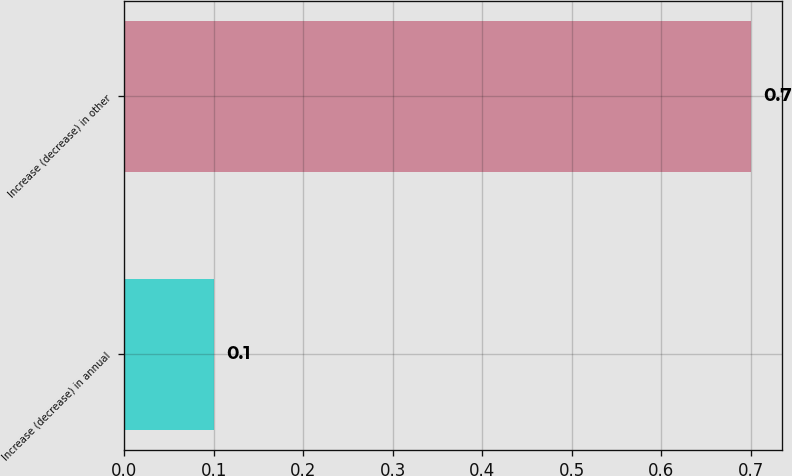Convert chart to OTSL. <chart><loc_0><loc_0><loc_500><loc_500><bar_chart><fcel>Increase (decrease) in annual<fcel>Increase (decrease) in other<nl><fcel>0.1<fcel>0.7<nl></chart> 